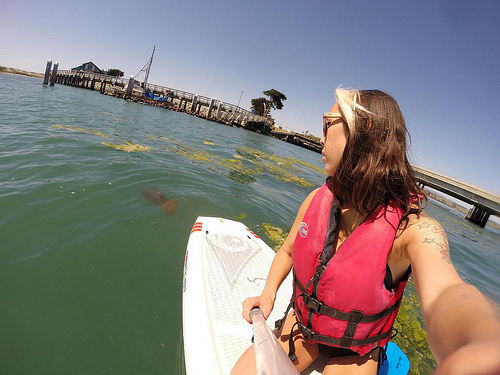<image>
Is there a woman on the wakeboard? Yes. Looking at the image, I can see the woman is positioned on top of the wakeboard, with the wakeboard providing support. 